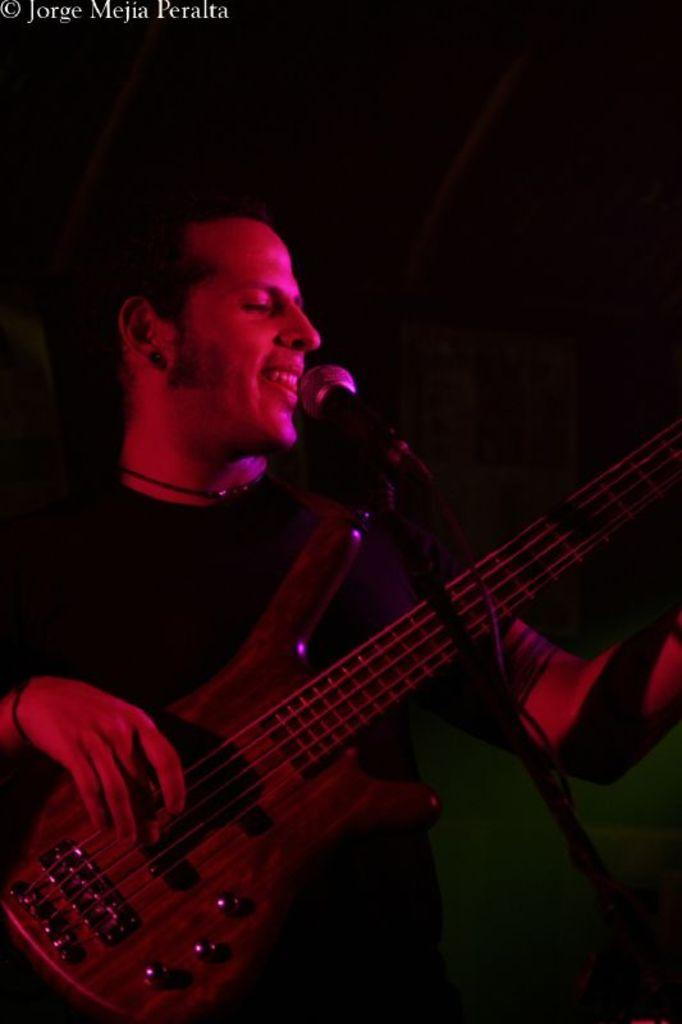What is the person in the image doing? The person is playing a guitar. What object is in front of the person? A microphone is present in front of the person. What is the person wearing? The person is wearing a black shirt. What position is the person in? The person is standing. Where is the throne located in the image? There is no throne present in the image. How does the person sneeze while playing the guitar in the image? The person is not sneezing in the image; they are playing the guitar. 